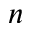Convert formula to latex. <formula><loc_0><loc_0><loc_500><loc_500>n</formula> 